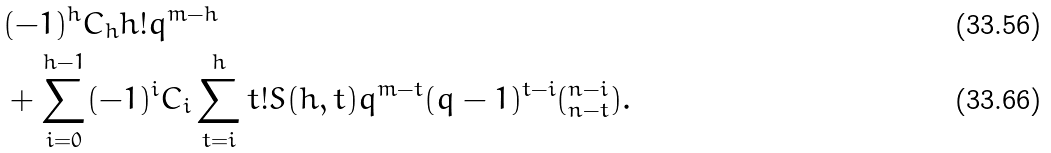Convert formula to latex. <formula><loc_0><loc_0><loc_500><loc_500>& ( - 1 ) ^ { h } C _ { h } h ! q ^ { m - h } \\ & + \sum _ { i = 0 } ^ { h - 1 } ( - 1 ) ^ { i } C _ { i } \sum _ { t = i } ^ { h } t ! S ( h , t ) q ^ { m - t } ( q - 1 ) ^ { t - i } ( ^ { n - i } _ { n - t } ) .</formula> 